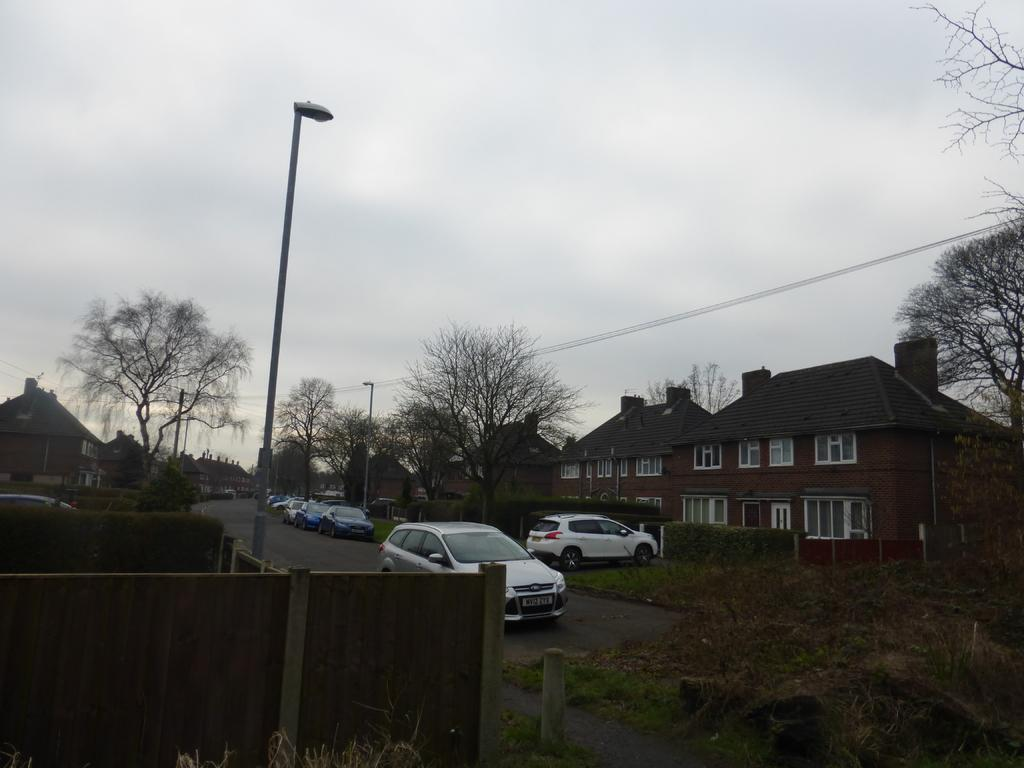What type of structures can be seen in the image? There are buildings in the image. What feature do the buildings have? The buildings have glass windows. What other natural elements are present in the image? There are trees in the image. What are the light-poles used for in the image? Light-poles are present in the image to provide illumination. What type of transportation is visible in the image? Vehicles are visible in the image. What type of barrier is present on the road? There is wooden fencing on the road. What is the color of the sky in the image? The sky is blue and white in color. Where is the tray located in the image? There is no tray present in the image. What type of religious building can be seen in the image? There is no church or any religious building present in the image. 